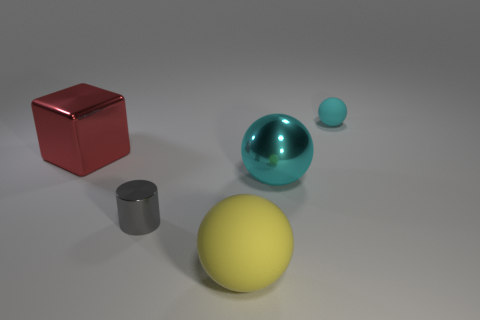Add 2 metal objects. How many objects exist? 7 Subtract all cubes. How many objects are left? 4 Subtract 0 purple cylinders. How many objects are left? 5 Subtract all tiny cyan rubber objects. Subtract all metallic things. How many objects are left? 1 Add 3 shiny cubes. How many shiny cubes are left? 4 Add 3 large metallic objects. How many large metallic objects exist? 5 